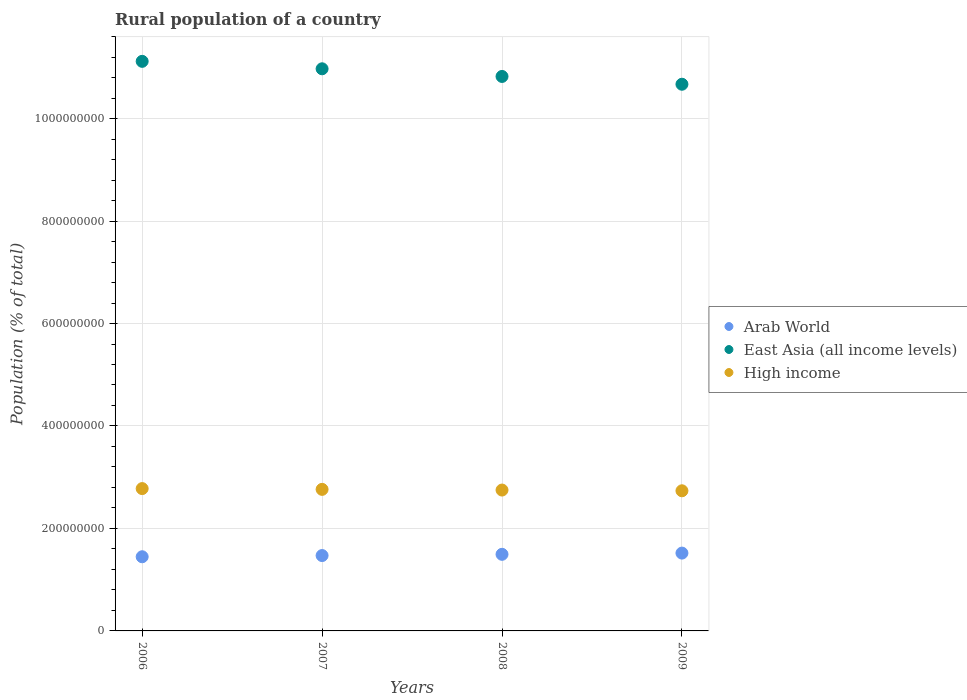How many different coloured dotlines are there?
Offer a very short reply. 3. What is the rural population in East Asia (all income levels) in 2007?
Offer a very short reply. 1.10e+09. Across all years, what is the maximum rural population in High income?
Give a very brief answer. 2.78e+08. Across all years, what is the minimum rural population in East Asia (all income levels)?
Provide a succinct answer. 1.07e+09. In which year was the rural population in Arab World maximum?
Keep it short and to the point. 2009. What is the total rural population in Arab World in the graph?
Ensure brevity in your answer.  5.93e+08. What is the difference between the rural population in High income in 2006 and that in 2008?
Offer a terse response. 2.85e+06. What is the difference between the rural population in East Asia (all income levels) in 2006 and the rural population in High income in 2007?
Ensure brevity in your answer.  8.35e+08. What is the average rural population in Arab World per year?
Offer a very short reply. 1.48e+08. In the year 2006, what is the difference between the rural population in Arab World and rural population in High income?
Make the answer very short. -1.33e+08. In how many years, is the rural population in East Asia (all income levels) greater than 920000000 %?
Provide a short and direct response. 4. What is the ratio of the rural population in Arab World in 2007 to that in 2008?
Keep it short and to the point. 0.98. Is the difference between the rural population in Arab World in 2006 and 2007 greater than the difference between the rural population in High income in 2006 and 2007?
Ensure brevity in your answer.  No. What is the difference between the highest and the second highest rural population in High income?
Your answer should be very brief. 1.51e+06. What is the difference between the highest and the lowest rural population in East Asia (all income levels)?
Make the answer very short. 4.47e+07. In how many years, is the rural population in Arab World greater than the average rural population in Arab World taken over all years?
Keep it short and to the point. 2. Is the sum of the rural population in High income in 2006 and 2008 greater than the maximum rural population in East Asia (all income levels) across all years?
Give a very brief answer. No. Does the rural population in High income monotonically increase over the years?
Make the answer very short. No. Is the rural population in Arab World strictly greater than the rural population in High income over the years?
Ensure brevity in your answer.  No. How many dotlines are there?
Your answer should be compact. 3. How many years are there in the graph?
Provide a succinct answer. 4. What is the difference between two consecutive major ticks on the Y-axis?
Your answer should be very brief. 2.00e+08. Does the graph contain any zero values?
Offer a very short reply. No. What is the title of the graph?
Your response must be concise. Rural population of a country. Does "Bosnia and Herzegovina" appear as one of the legend labels in the graph?
Offer a terse response. No. What is the label or title of the Y-axis?
Provide a succinct answer. Population (% of total). What is the Population (% of total) of Arab World in 2006?
Ensure brevity in your answer.  1.45e+08. What is the Population (% of total) of East Asia (all income levels) in 2006?
Your answer should be very brief. 1.11e+09. What is the Population (% of total) in High income in 2006?
Offer a very short reply. 2.78e+08. What is the Population (% of total) in Arab World in 2007?
Your answer should be very brief. 1.47e+08. What is the Population (% of total) in East Asia (all income levels) in 2007?
Keep it short and to the point. 1.10e+09. What is the Population (% of total) in High income in 2007?
Your answer should be very brief. 2.76e+08. What is the Population (% of total) of Arab World in 2008?
Provide a short and direct response. 1.50e+08. What is the Population (% of total) in East Asia (all income levels) in 2008?
Keep it short and to the point. 1.08e+09. What is the Population (% of total) of High income in 2008?
Give a very brief answer. 2.75e+08. What is the Population (% of total) in Arab World in 2009?
Your answer should be very brief. 1.52e+08. What is the Population (% of total) in East Asia (all income levels) in 2009?
Keep it short and to the point. 1.07e+09. What is the Population (% of total) of High income in 2009?
Keep it short and to the point. 2.74e+08. Across all years, what is the maximum Population (% of total) in Arab World?
Your response must be concise. 1.52e+08. Across all years, what is the maximum Population (% of total) in East Asia (all income levels)?
Ensure brevity in your answer.  1.11e+09. Across all years, what is the maximum Population (% of total) in High income?
Your response must be concise. 2.78e+08. Across all years, what is the minimum Population (% of total) of Arab World?
Your answer should be very brief. 1.45e+08. Across all years, what is the minimum Population (% of total) of East Asia (all income levels)?
Ensure brevity in your answer.  1.07e+09. Across all years, what is the minimum Population (% of total) of High income?
Provide a short and direct response. 2.74e+08. What is the total Population (% of total) of Arab World in the graph?
Offer a very short reply. 5.93e+08. What is the total Population (% of total) in East Asia (all income levels) in the graph?
Ensure brevity in your answer.  4.36e+09. What is the total Population (% of total) of High income in the graph?
Provide a succinct answer. 1.10e+09. What is the difference between the Population (% of total) of Arab World in 2006 and that in 2007?
Your response must be concise. -2.35e+06. What is the difference between the Population (% of total) of East Asia (all income levels) in 2006 and that in 2007?
Your response must be concise. 1.45e+07. What is the difference between the Population (% of total) of High income in 2006 and that in 2007?
Offer a terse response. 1.51e+06. What is the difference between the Population (% of total) in Arab World in 2006 and that in 2008?
Offer a terse response. -4.75e+06. What is the difference between the Population (% of total) in East Asia (all income levels) in 2006 and that in 2008?
Your response must be concise. 2.95e+07. What is the difference between the Population (% of total) in High income in 2006 and that in 2008?
Provide a succinct answer. 2.85e+06. What is the difference between the Population (% of total) of Arab World in 2006 and that in 2009?
Your response must be concise. -7.14e+06. What is the difference between the Population (% of total) in East Asia (all income levels) in 2006 and that in 2009?
Offer a terse response. 4.47e+07. What is the difference between the Population (% of total) in High income in 2006 and that in 2009?
Your answer should be very brief. 4.28e+06. What is the difference between the Population (% of total) in Arab World in 2007 and that in 2008?
Ensure brevity in your answer.  -2.40e+06. What is the difference between the Population (% of total) of East Asia (all income levels) in 2007 and that in 2008?
Make the answer very short. 1.49e+07. What is the difference between the Population (% of total) of High income in 2007 and that in 2008?
Your response must be concise. 1.33e+06. What is the difference between the Population (% of total) in Arab World in 2007 and that in 2009?
Provide a succinct answer. -4.79e+06. What is the difference between the Population (% of total) of East Asia (all income levels) in 2007 and that in 2009?
Give a very brief answer. 3.02e+07. What is the difference between the Population (% of total) of High income in 2007 and that in 2009?
Give a very brief answer. 2.77e+06. What is the difference between the Population (% of total) of Arab World in 2008 and that in 2009?
Provide a succinct answer. -2.39e+06. What is the difference between the Population (% of total) of East Asia (all income levels) in 2008 and that in 2009?
Provide a short and direct response. 1.52e+07. What is the difference between the Population (% of total) in High income in 2008 and that in 2009?
Your answer should be very brief. 1.44e+06. What is the difference between the Population (% of total) in Arab World in 2006 and the Population (% of total) in East Asia (all income levels) in 2007?
Ensure brevity in your answer.  -9.52e+08. What is the difference between the Population (% of total) of Arab World in 2006 and the Population (% of total) of High income in 2007?
Keep it short and to the point. -1.32e+08. What is the difference between the Population (% of total) of East Asia (all income levels) in 2006 and the Population (% of total) of High income in 2007?
Provide a succinct answer. 8.35e+08. What is the difference between the Population (% of total) in Arab World in 2006 and the Population (% of total) in East Asia (all income levels) in 2008?
Provide a succinct answer. -9.37e+08. What is the difference between the Population (% of total) of Arab World in 2006 and the Population (% of total) of High income in 2008?
Your answer should be compact. -1.30e+08. What is the difference between the Population (% of total) in East Asia (all income levels) in 2006 and the Population (% of total) in High income in 2008?
Keep it short and to the point. 8.37e+08. What is the difference between the Population (% of total) of Arab World in 2006 and the Population (% of total) of East Asia (all income levels) in 2009?
Offer a terse response. -9.22e+08. What is the difference between the Population (% of total) in Arab World in 2006 and the Population (% of total) in High income in 2009?
Provide a succinct answer. -1.29e+08. What is the difference between the Population (% of total) of East Asia (all income levels) in 2006 and the Population (% of total) of High income in 2009?
Your response must be concise. 8.38e+08. What is the difference between the Population (% of total) in Arab World in 2007 and the Population (% of total) in East Asia (all income levels) in 2008?
Offer a very short reply. -9.35e+08. What is the difference between the Population (% of total) in Arab World in 2007 and the Population (% of total) in High income in 2008?
Keep it short and to the point. -1.28e+08. What is the difference between the Population (% of total) in East Asia (all income levels) in 2007 and the Population (% of total) in High income in 2008?
Make the answer very short. 8.22e+08. What is the difference between the Population (% of total) of Arab World in 2007 and the Population (% of total) of East Asia (all income levels) in 2009?
Give a very brief answer. -9.20e+08. What is the difference between the Population (% of total) in Arab World in 2007 and the Population (% of total) in High income in 2009?
Ensure brevity in your answer.  -1.26e+08. What is the difference between the Population (% of total) in East Asia (all income levels) in 2007 and the Population (% of total) in High income in 2009?
Offer a very short reply. 8.24e+08. What is the difference between the Population (% of total) of Arab World in 2008 and the Population (% of total) of East Asia (all income levels) in 2009?
Keep it short and to the point. -9.17e+08. What is the difference between the Population (% of total) in Arab World in 2008 and the Population (% of total) in High income in 2009?
Provide a succinct answer. -1.24e+08. What is the difference between the Population (% of total) of East Asia (all income levels) in 2008 and the Population (% of total) of High income in 2009?
Give a very brief answer. 8.09e+08. What is the average Population (% of total) in Arab World per year?
Offer a very short reply. 1.48e+08. What is the average Population (% of total) of East Asia (all income levels) per year?
Offer a very short reply. 1.09e+09. What is the average Population (% of total) of High income per year?
Give a very brief answer. 2.76e+08. In the year 2006, what is the difference between the Population (% of total) of Arab World and Population (% of total) of East Asia (all income levels)?
Keep it short and to the point. -9.67e+08. In the year 2006, what is the difference between the Population (% of total) of Arab World and Population (% of total) of High income?
Your response must be concise. -1.33e+08. In the year 2006, what is the difference between the Population (% of total) in East Asia (all income levels) and Population (% of total) in High income?
Provide a succinct answer. 8.34e+08. In the year 2007, what is the difference between the Population (% of total) in Arab World and Population (% of total) in East Asia (all income levels)?
Ensure brevity in your answer.  -9.50e+08. In the year 2007, what is the difference between the Population (% of total) of Arab World and Population (% of total) of High income?
Keep it short and to the point. -1.29e+08. In the year 2007, what is the difference between the Population (% of total) in East Asia (all income levels) and Population (% of total) in High income?
Provide a short and direct response. 8.21e+08. In the year 2008, what is the difference between the Population (% of total) in Arab World and Population (% of total) in East Asia (all income levels)?
Make the answer very short. -9.33e+08. In the year 2008, what is the difference between the Population (% of total) in Arab World and Population (% of total) in High income?
Keep it short and to the point. -1.25e+08. In the year 2008, what is the difference between the Population (% of total) in East Asia (all income levels) and Population (% of total) in High income?
Your answer should be compact. 8.07e+08. In the year 2009, what is the difference between the Population (% of total) in Arab World and Population (% of total) in East Asia (all income levels)?
Provide a short and direct response. -9.15e+08. In the year 2009, what is the difference between the Population (% of total) of Arab World and Population (% of total) of High income?
Make the answer very short. -1.22e+08. In the year 2009, what is the difference between the Population (% of total) in East Asia (all income levels) and Population (% of total) in High income?
Provide a succinct answer. 7.93e+08. What is the ratio of the Population (% of total) in Arab World in 2006 to that in 2007?
Make the answer very short. 0.98. What is the ratio of the Population (% of total) in East Asia (all income levels) in 2006 to that in 2007?
Provide a short and direct response. 1.01. What is the ratio of the Population (% of total) in Arab World in 2006 to that in 2008?
Provide a succinct answer. 0.97. What is the ratio of the Population (% of total) in East Asia (all income levels) in 2006 to that in 2008?
Ensure brevity in your answer.  1.03. What is the ratio of the Population (% of total) of High income in 2006 to that in 2008?
Give a very brief answer. 1.01. What is the ratio of the Population (% of total) in Arab World in 2006 to that in 2009?
Your response must be concise. 0.95. What is the ratio of the Population (% of total) in East Asia (all income levels) in 2006 to that in 2009?
Give a very brief answer. 1.04. What is the ratio of the Population (% of total) in High income in 2006 to that in 2009?
Keep it short and to the point. 1.02. What is the ratio of the Population (% of total) in Arab World in 2007 to that in 2008?
Give a very brief answer. 0.98. What is the ratio of the Population (% of total) in East Asia (all income levels) in 2007 to that in 2008?
Offer a very short reply. 1.01. What is the ratio of the Population (% of total) of High income in 2007 to that in 2008?
Offer a terse response. 1. What is the ratio of the Population (% of total) of Arab World in 2007 to that in 2009?
Offer a very short reply. 0.97. What is the ratio of the Population (% of total) in East Asia (all income levels) in 2007 to that in 2009?
Provide a succinct answer. 1.03. What is the ratio of the Population (% of total) of High income in 2007 to that in 2009?
Offer a very short reply. 1.01. What is the ratio of the Population (% of total) in Arab World in 2008 to that in 2009?
Make the answer very short. 0.98. What is the ratio of the Population (% of total) in East Asia (all income levels) in 2008 to that in 2009?
Your response must be concise. 1.01. What is the difference between the highest and the second highest Population (% of total) of Arab World?
Your answer should be compact. 2.39e+06. What is the difference between the highest and the second highest Population (% of total) of East Asia (all income levels)?
Give a very brief answer. 1.45e+07. What is the difference between the highest and the second highest Population (% of total) in High income?
Offer a terse response. 1.51e+06. What is the difference between the highest and the lowest Population (% of total) in Arab World?
Your answer should be very brief. 7.14e+06. What is the difference between the highest and the lowest Population (% of total) of East Asia (all income levels)?
Provide a succinct answer. 4.47e+07. What is the difference between the highest and the lowest Population (% of total) of High income?
Make the answer very short. 4.28e+06. 